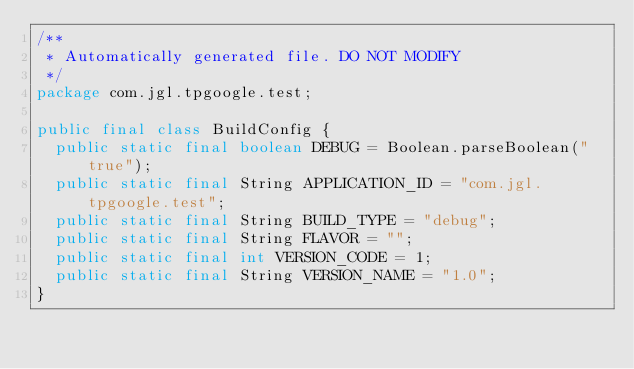<code> <loc_0><loc_0><loc_500><loc_500><_Java_>/**
 * Automatically generated file. DO NOT MODIFY
 */
package com.jgl.tpgoogle.test;

public final class BuildConfig {
  public static final boolean DEBUG = Boolean.parseBoolean("true");
  public static final String APPLICATION_ID = "com.jgl.tpgoogle.test";
  public static final String BUILD_TYPE = "debug";
  public static final String FLAVOR = "";
  public static final int VERSION_CODE = 1;
  public static final String VERSION_NAME = "1.0";
}
</code> 